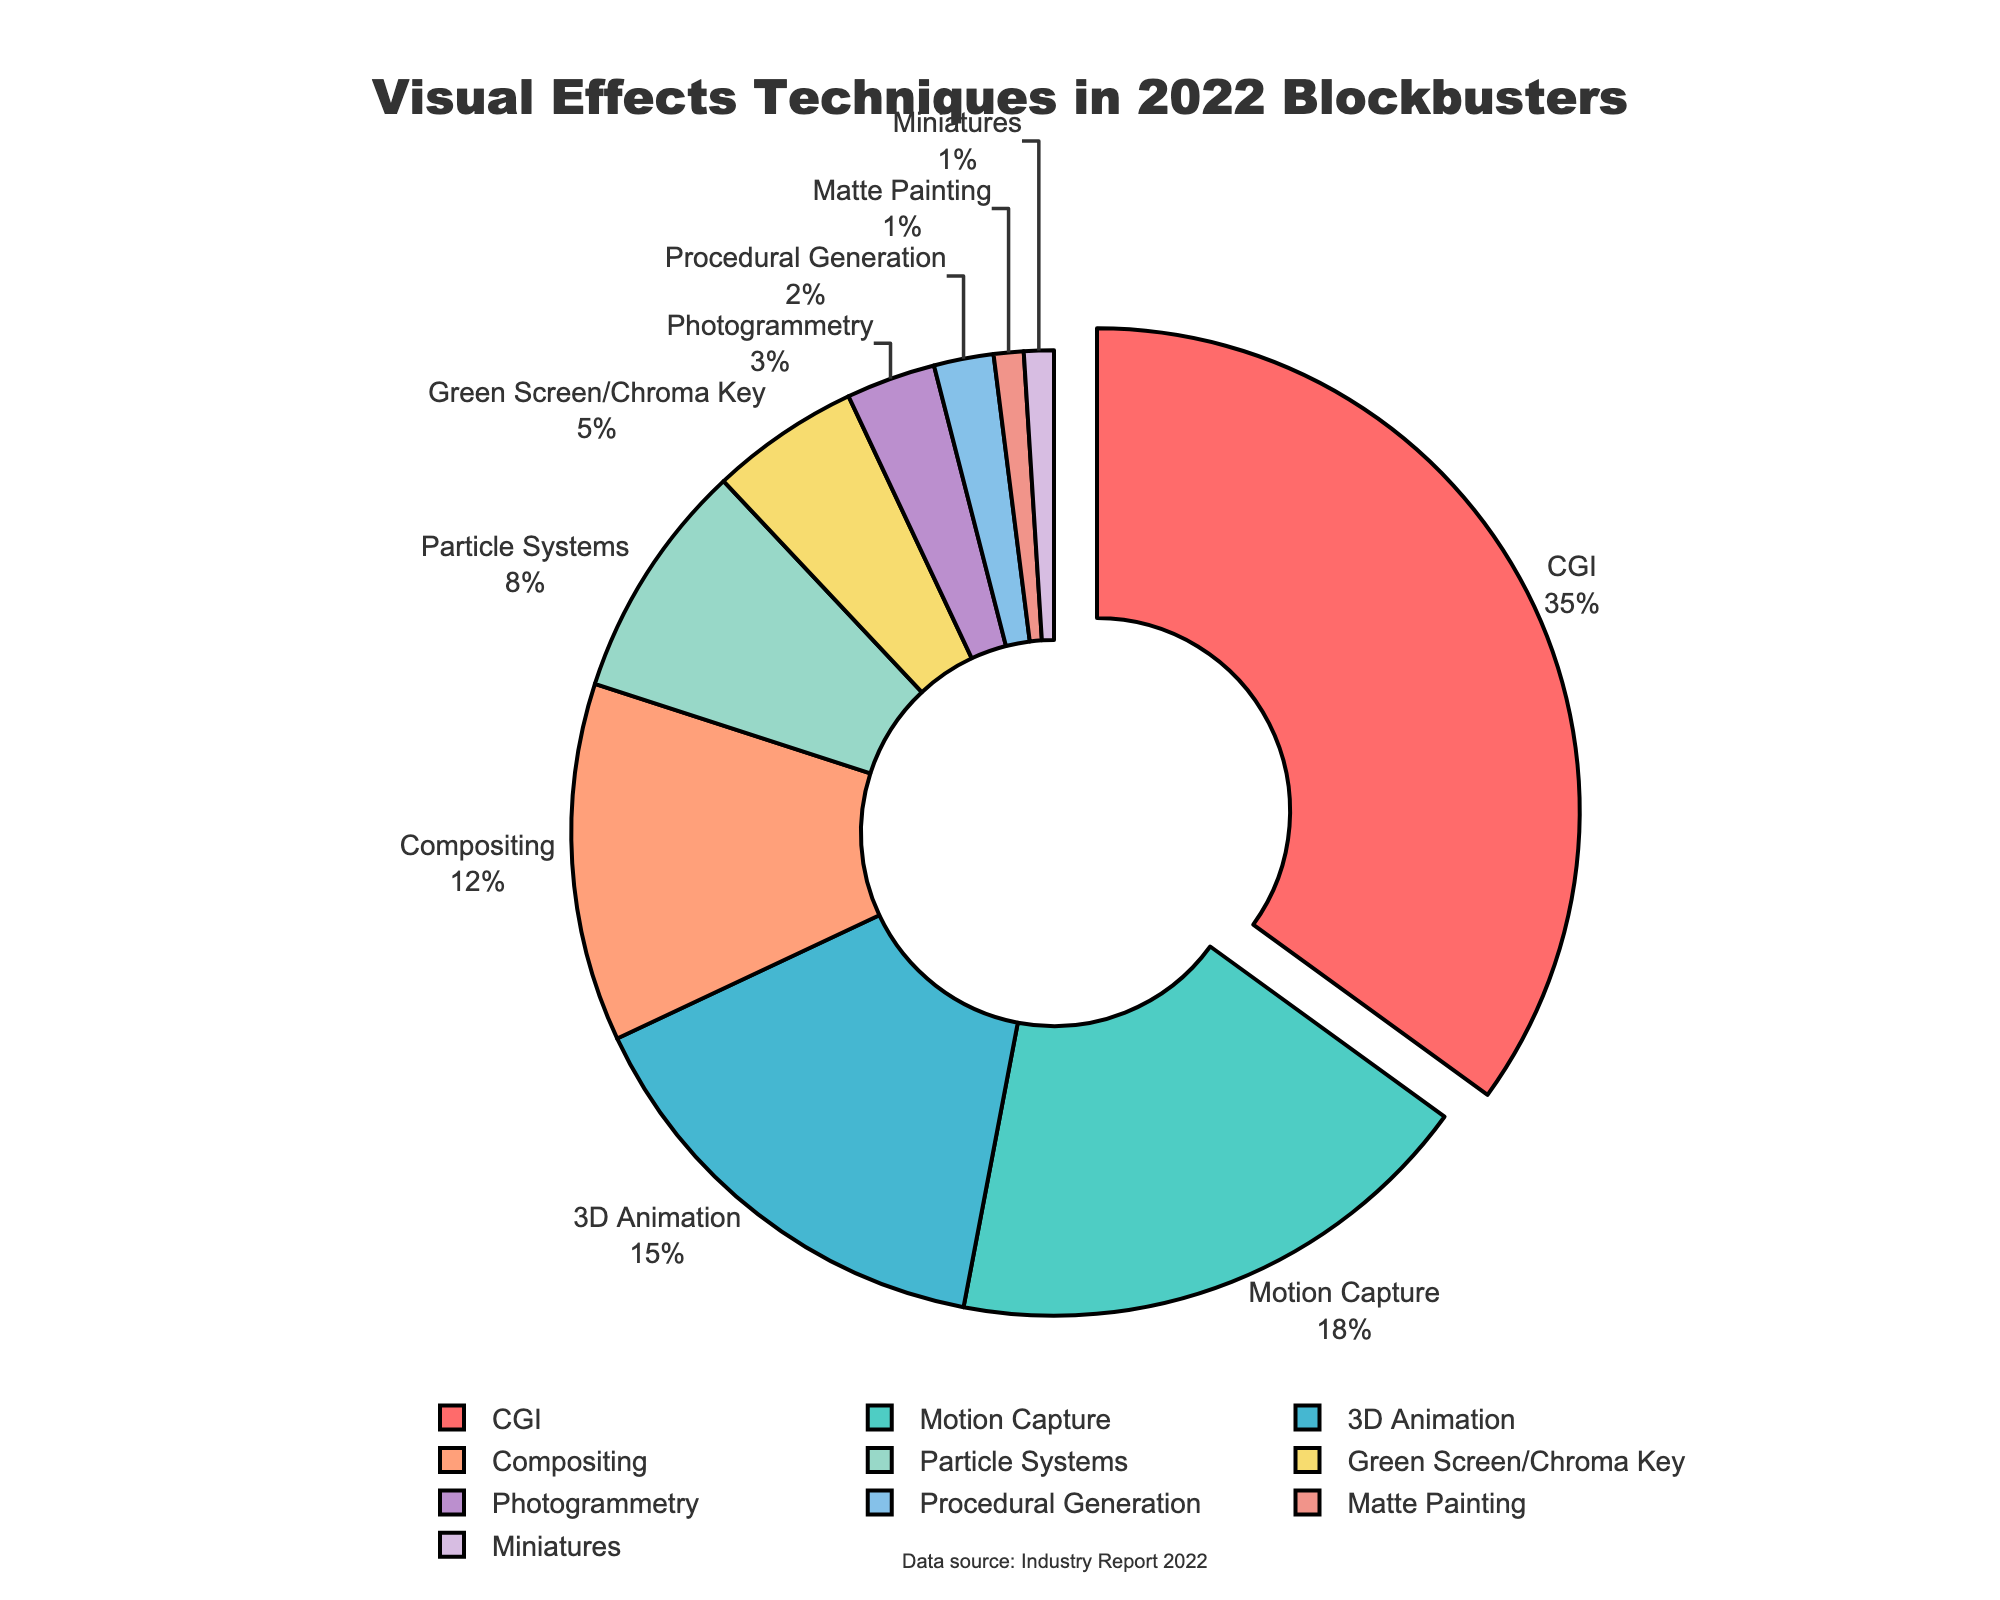what is the most common visual effects technique used in blockbuster movies of 2022? The figure shows that 'CGI' (Computer-Generated Imagery) occupies the largest portion of the pie chart, and it is also pulled out slightly to highlight its predominance.
Answer: CGI how many techniques together account for more than half (over 50%) of the visual effects used? By looking at the pie chart, we can sum the percentages of the largest segments until we reach over 50%. CGI (35%) + Motion Capture (18%) = 53%, which is more than half of the visual effects techniques.
Answer: 2 which technique is represented with the smallest portion of the pie chart? Observing the pie chart, 'Miniatures' and 'Matte Painting' both occupy the smallest portion, each representing 1%.
Answer: Miniatures and Matte Painting what is the difference in percentage between the most used and least used techniques? The most used technique is CGI (35%) and the least used techniques are Miniatures and Matte Painting (1% each). The difference is calculated as 35% - 1% = 34%.
Answer: 34% what color represents the Motion Capture technique in the pie chart? The pie chart uses different colors for each segment. Motion Capture is represented in the second position from the top, colored in green (using the second color in our list).
Answer: green if '3D Animation' and 'Compositing' are combined into a new category, what percentage of the total visual effects techniques would it represent? Adding the percentages of '3D Animation' (15%) and 'Compositing' (12%) results in a total of 15% + 12% = 27%.
Answer: 27% how much more percentage does 'Particle Systems' have compared to 'Green Screen/Chroma Key'? The percentages are Particle Systems (8%) and Green Screen/Chroma Key (5%), so the difference is 8% - 5% = 3%.
Answer: 3% what is the combined percentage of 'Photogrammetry' and 'Procedural Generation'? By summing the percentages of 'Photogrammetry' (3%) and 'Procedural Generation' (2%), we get a total of 3% + 2% = 5%.
Answer: 5% how does the percentage of 'Procedural Generation' compare to 'Miniatures'? 'Procedural Generation' represents 2%, while 'Miniatures' represent 1%. Therefore, 'Procedural Generation' is double the percentage of 'Miniatures'.
Answer: double 